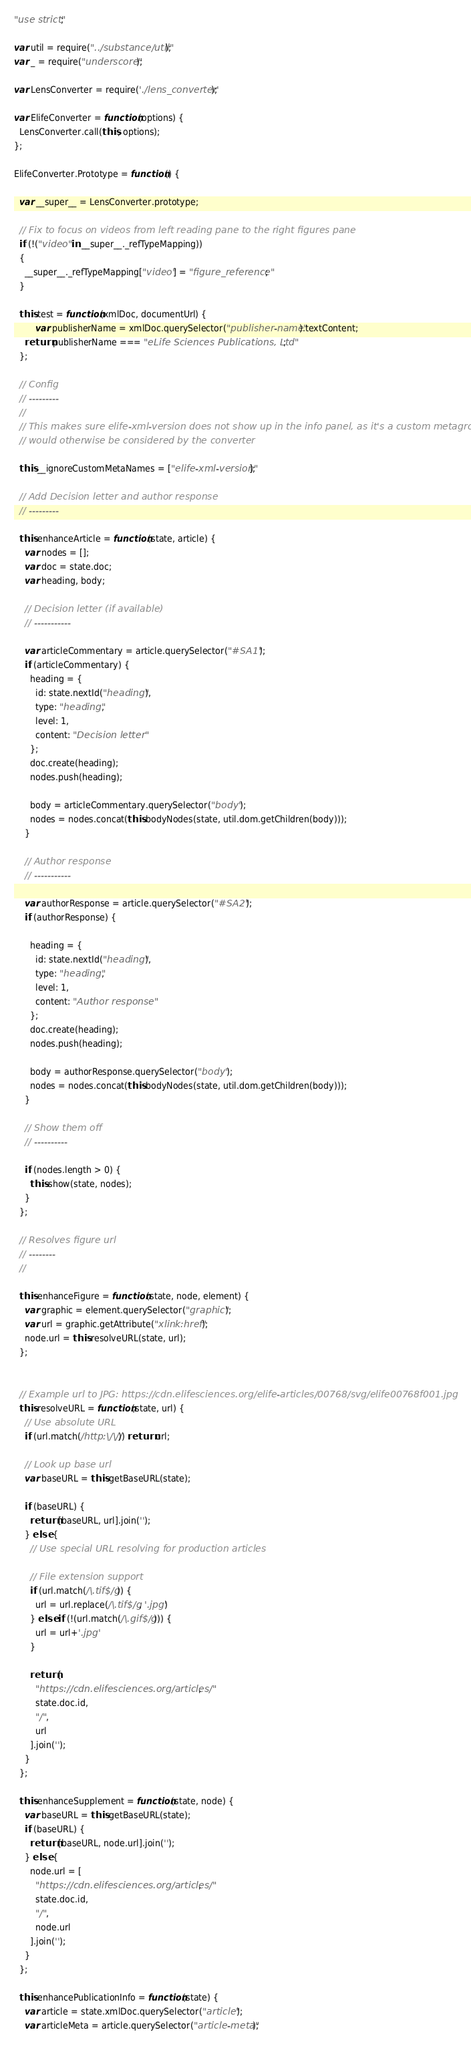<code> <loc_0><loc_0><loc_500><loc_500><_JavaScript_>"use strict";

var util = require("../substance/util");
var _ = require("underscore");

var LensConverter = require('./lens_converter');

var ElifeConverter = function(options) {
  LensConverter.call(this, options);
};

ElifeConverter.Prototype = function() {

  var __super__ = LensConverter.prototype;

  // Fix to focus on videos from left reading pane to the right figures pane
  if (!("video" in __super__._refTypeMapping))
  {
    __super__._refTypeMapping["video"] = "figure_reference";
  }

  this.test = function(xmlDoc, documentUrl) {
		var publisherName = xmlDoc.querySelector("publisher-name").textContent;
    return publisherName === "eLife Sciences Publications, Ltd";
  };

  // Config
  // ---------
  //
  // This makes sure elife-xml-version does not show up in the info panel, as it's a custom metagroup that
  // would otherwise be considered by the converter

  this.__ignoreCustomMetaNames = ["elife-xml-version"];

  // Add Decision letter and author response
  // ---------

  this.enhanceArticle = function(state, article) {
    var nodes = [];
    var doc = state.doc;
    var heading, body;

    // Decision letter (if available)
    // -----------

    var articleCommentary = article.querySelector("#SA1");
    if (articleCommentary) {
      heading = {
        id: state.nextId("heading"),
        type: "heading",
        level: 1,
        content: "Decision letter"
      };
      doc.create(heading);
      nodes.push(heading);

      body = articleCommentary.querySelector("body");
      nodes = nodes.concat(this.bodyNodes(state, util.dom.getChildren(body)));
    }

    // Author response
    // -----------

    var authorResponse = article.querySelector("#SA2");
    if (authorResponse) {

      heading = {
        id: state.nextId("heading"),
        type: "heading",
        level: 1,
        content: "Author response"
      };
      doc.create(heading);
      nodes.push(heading);

      body = authorResponse.querySelector("body");
      nodes = nodes.concat(this.bodyNodes(state, util.dom.getChildren(body)));
    }

    // Show them off
    // ----------

    if (nodes.length > 0) {
      this.show(state, nodes);
    }
  };

  // Resolves figure url
  // --------
  //

  this.enhanceFigure = function(state, node, element) {
    var graphic = element.querySelector("graphic");
    var url = graphic.getAttribute("xlink:href");
    node.url = this.resolveURL(state, url);
  };


  // Example url to JPG: https://cdn.elifesciences.org/elife-articles/00768/svg/elife00768f001.jpg
  this.resolveURL = function(state, url) {
    // Use absolute URL
    if (url.match(/http:\/\//)) return url;

    // Look up base url
    var baseURL = this.getBaseURL(state);

    if (baseURL) {
      return [baseURL, url].join('');
    } else {
      // Use special URL resolving for production articles

      // File extension support
      if (url.match(/\.tif$/g)) {
        url = url.replace(/\.tif$/g, '.jpg')
      } else if (!(url.match(/\.gif$/g))) {
        url = url+'.jpg'
      }

      return [
        "https://cdn.elifesciences.org/articles/",
        state.doc.id,
        "/",
        url
      ].join('');
    }
  };

  this.enhanceSupplement = function(state, node) {
    var baseURL = this.getBaseURL(state);
    if (baseURL) {
      return [baseURL, node.url].join('');
    } else {
      node.url = [
        "https://cdn.elifesciences.org/articles/",
        state.doc.id,
        "/",
        node.url
      ].join('');
    }
  };

  this.enhancePublicationInfo = function(state) {
    var article = state.xmlDoc.querySelector("article");
    var articleMeta = article.querySelector("article-meta");
</code> 